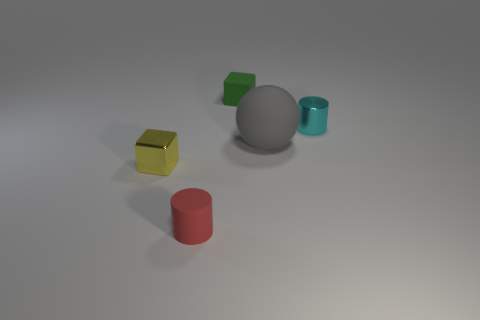Are there an equal number of tiny yellow cubes that are on the right side of the small red cylinder and big gray metallic spheres? Yes, there is an equal number of tiny yellow cubes on the right side of the small red cylinder and big gray metallic spheres. To elaborate, when observing the scene, we can count the tiny yellow cubes and find that their number matches the quantity of the larger gray spheres, allowing for symmetry in the arrangement. 